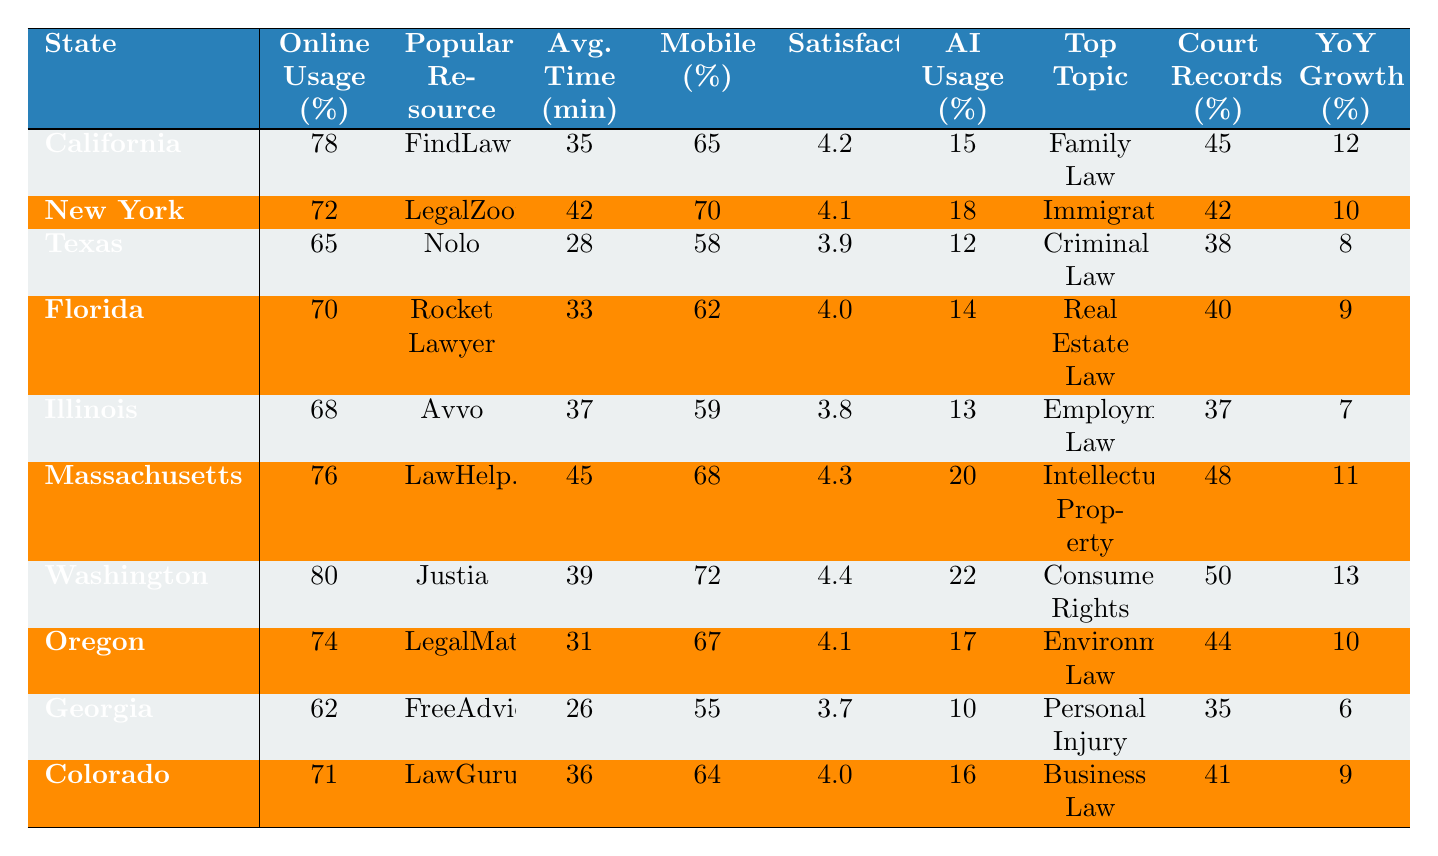What is the most popular legal resource in California? By referring to the table, California has "FindLaw" listed as its most popular legal resource.
Answer: FindLaw Which state has the highest percentage of online legal service usage? Looking at the percentages in the table, Washington has the highest usage at 80%.
Answer: Washington What is the average time spent per session in New York? According to the table, the average time spent per session in New York is 42 minutes.
Answer: 42 minutes What percentage of users in Florida access legal services via mobile? The table indicates that 62% of users in Florida access legal services via mobile.
Answer: 62% Is user satisfaction in Georgia higher than in Texas? User satisfaction in Georgia is 3.7, while in Texas it is 3.9. Since 3.7 is less than 3.9, the statement is false.
Answer: No What is the difference in online legal service usage percentage between California and Illinois? California has an online usage percentage of 78%, and Illinois has 68%. The difference is 78% - 68% = 10%.
Answer: 10% In which state is the most searched legal topic "Consumer Rights"? The table shows that "Consumer Rights" is the most searched legal topic in Washington.
Answer: Washington What is the average user satisfaction rating for all states listed? To find the average, sum the user satisfaction ratings (4.2 + 4.1 + 3.9 + 4.0 + 3.8 + 4.3 + 4.4 + 4.1 + 3.7 + 4.0 = 40.5) and divide by the number of states (10). The average user satisfaction rating is 40.5 / 10 = 4.05.
Answer: 4.05 Which state has the lowest percentage of people using AI legal assistants? The table shows the percentages for AI legal assistants. Georgia has the lowest percentage at 10%.
Answer: Georgia What is the growth in online legal resource usage year over year for Massachusetts? Massachusetts has a growth rate of 11% according to the table.
Answer: 11% 